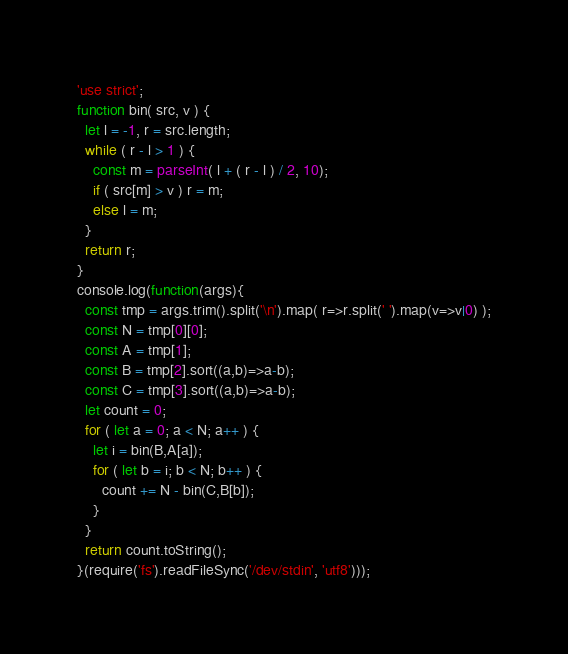Convert code to text. <code><loc_0><loc_0><loc_500><loc_500><_JavaScript_>'use strict';
function bin( src, v ) {
  let l = -1, r = src.length;
  while ( r - l > 1 ) {
    const m = parseInt( l + ( r - l ) / 2, 10);
    if ( src[m] > v ) r = m;
    else l = m;
  }
  return r;
}
console.log(function(args){
  const tmp = args.trim().split('\n').map( r=>r.split(' ').map(v=>v|0) );
  const N = tmp[0][0];
  const A = tmp[1];
  const B = tmp[2].sort((a,b)=>a-b);
  const C = tmp[3].sort((a,b)=>a-b);
  let count = 0;
  for ( let a = 0; a < N; a++ ) {
    let i = bin(B,A[a]);
    for ( let b = i; b < N; b++ ) {
      count += N - bin(C,B[b]);
    }
  }
  return count.toString();
}(require('fs').readFileSync('/dev/stdin', 'utf8')));
</code> 